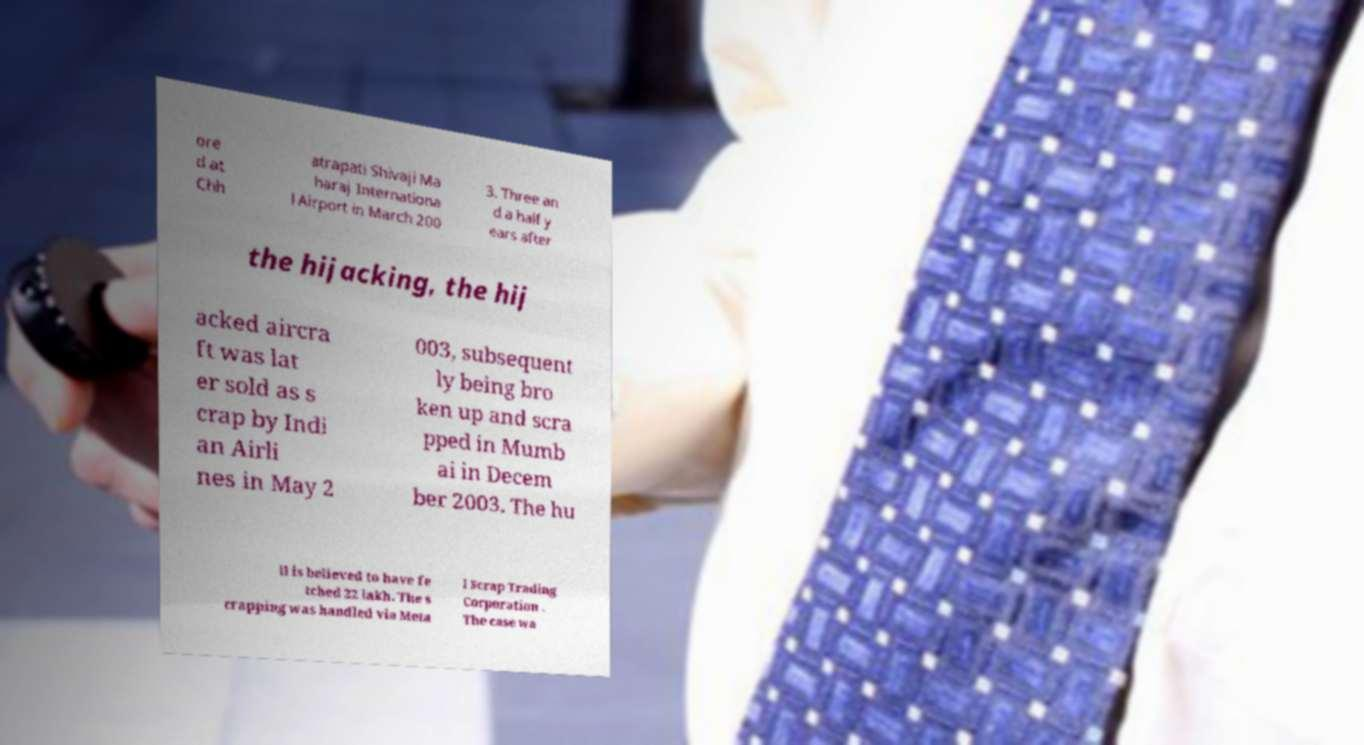Please read and relay the text visible in this image. What does it say? ore d at Chh atrapati Shivaji Ma haraj Internationa l Airport in March 200 3. Three an d a half y ears after the hijacking, the hij acked aircra ft was lat er sold as s crap by Indi an Airli nes in May 2 003, subsequent ly being bro ken up and scra pped in Mumb ai in Decem ber 2003. The hu ll is believed to have fe tched 22 lakh. The s crapping was handled via Meta l Scrap Trading Corporation . The case wa 